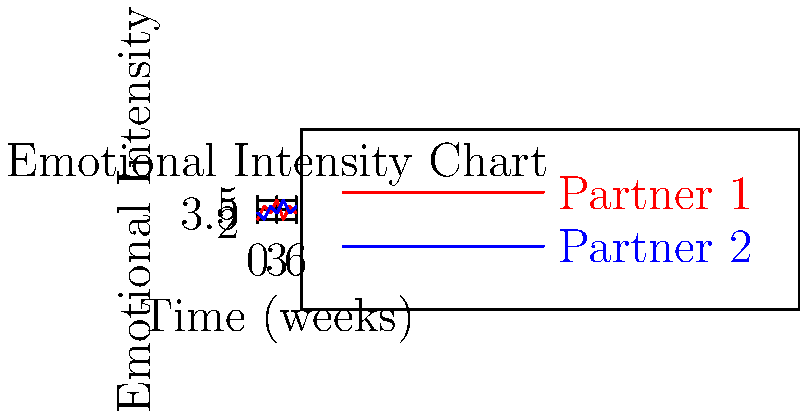Based on the emotional intensity chart of a potential adoptive couple over six weeks, what conclusion can you draw about their relationship dynamics? To interpret the emotional intensity chart and assess the couple's relationship dynamics, follow these steps:

1. Observe the overall pattern:
   - Both partners show fluctuations in emotional intensity over time.
   - The lines intersect multiple times, indicating changing dynamics.

2. Analyze individual patterns:
   - Partner 1 (red line) shows more dramatic ups and downs.
   - Partner 2 (blue line) has a more stable pattern with smaller fluctuations.

3. Compare the partners:
   - When one partner's emotional intensity increases, the other's often decreases.
   - This suggests a complementary emotional response between the partners.

4. Consider the implications:
   - The alternating pattern indicates that the partners may be responsive to each other's emotional states.
   - The couple appears to have a balanced dynamic where they take turns supporting each other emotionally.

5. Evaluate stability:
   - Despite fluctuations, both partners remain within a consistent range of emotional intensity (between 2 and 5).
   - This suggests overall emotional stability in the relationship.

6. Assess compatibility:
   - The complementary nature of their emotional patterns indicates good emotional attunement.
   - This could be a positive sign for their ability to handle the emotional challenges of adoption.

Conclusion: The chart suggests a couple with complementary emotional responses, indicating a supportive and balanced relationship dynamic that could be well-suited for the challenges of adoption.
Answer: Complementary emotional support 